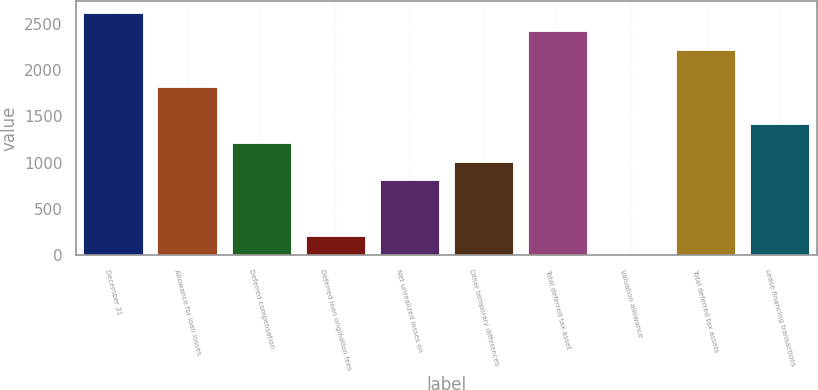<chart> <loc_0><loc_0><loc_500><loc_500><bar_chart><fcel>December 31<fcel>Allowance for loan losses<fcel>Deferred compensation<fcel>Deferred loan origination fees<fcel>Net unrealized losses on<fcel>Other temporary differences<fcel>Total deferred tax asset<fcel>Valuation allowance<fcel>Total deferred tax assets<fcel>Lease financing transactions<nl><fcel>2622.5<fcel>1816.5<fcel>1212<fcel>204.5<fcel>809<fcel>1010.5<fcel>2421<fcel>3<fcel>2219.5<fcel>1413.5<nl></chart> 